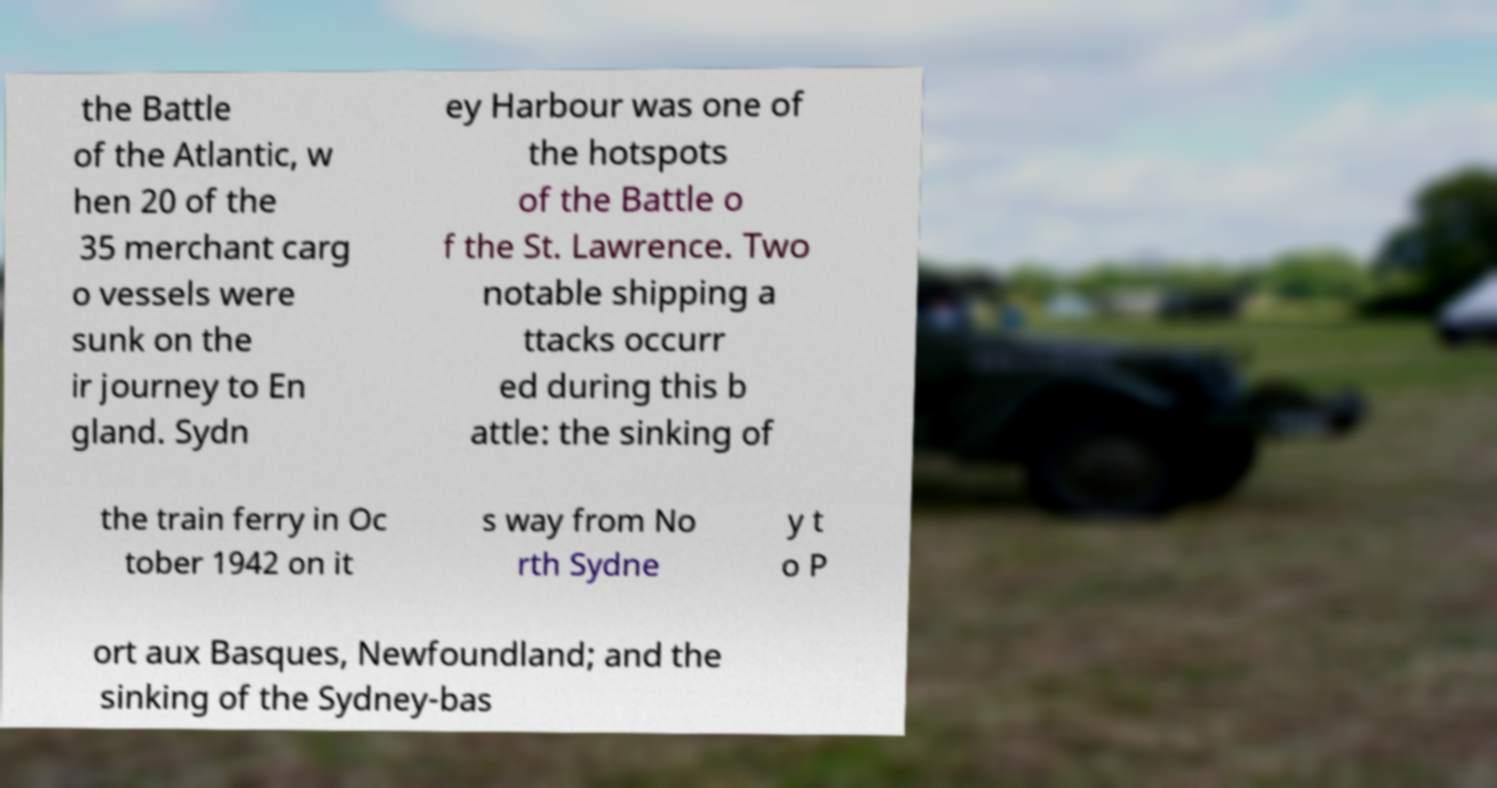Could you extract and type out the text from this image? the Battle of the Atlantic, w hen 20 of the 35 merchant carg o vessels were sunk on the ir journey to En gland. Sydn ey Harbour was one of the hotspots of the Battle o f the St. Lawrence. Two notable shipping a ttacks occurr ed during this b attle: the sinking of the train ferry in Oc tober 1942 on it s way from No rth Sydne y t o P ort aux Basques, Newfoundland; and the sinking of the Sydney-bas 